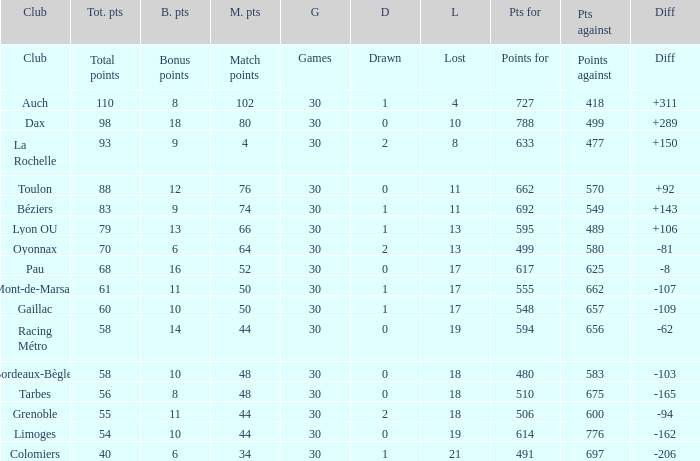How many bonus points did the Colomiers earn? 6.0. 